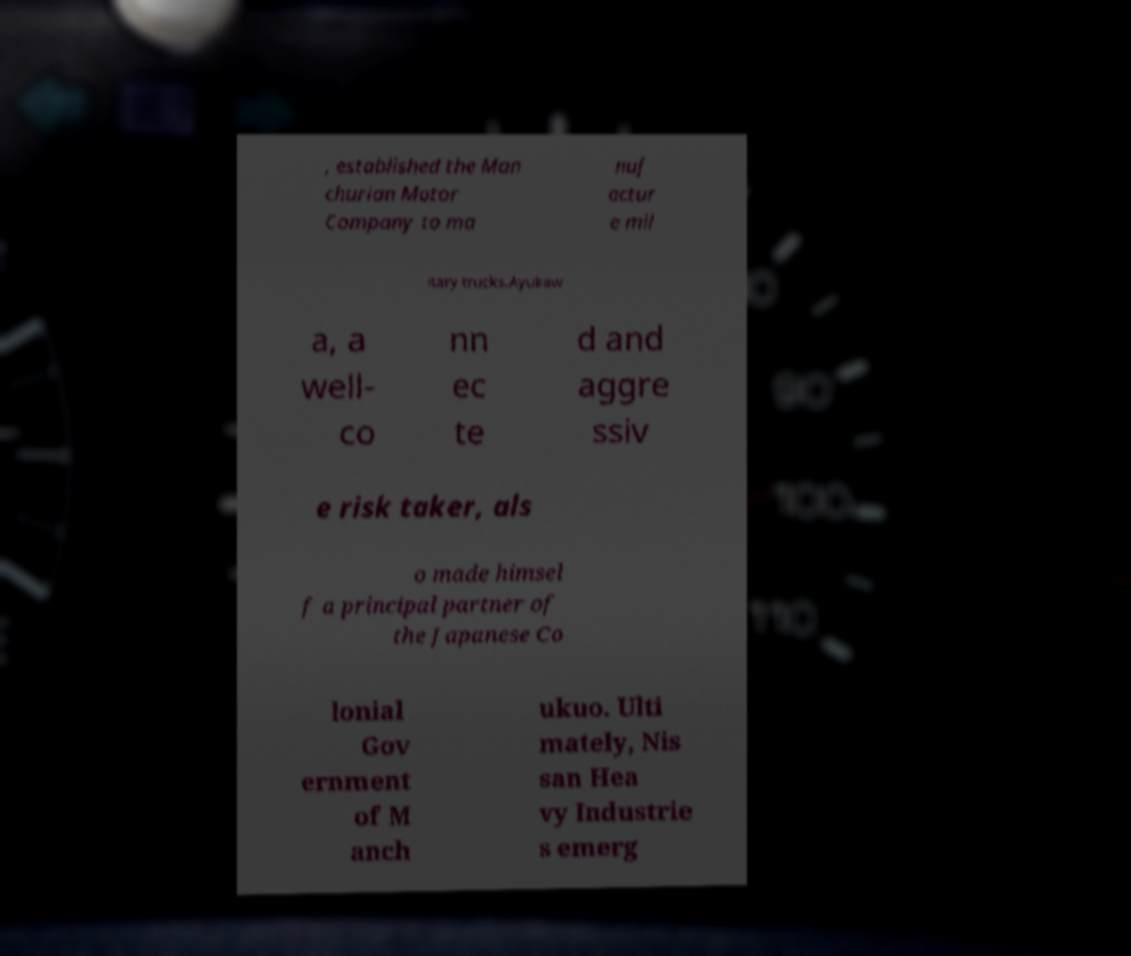Can you accurately transcribe the text from the provided image for me? , established the Man churian Motor Company to ma nuf actur e mil itary trucks.Ayukaw a, a well- co nn ec te d and aggre ssiv e risk taker, als o made himsel f a principal partner of the Japanese Co lonial Gov ernment of M anch ukuo. Ulti mately, Nis san Hea vy Industrie s emerg 